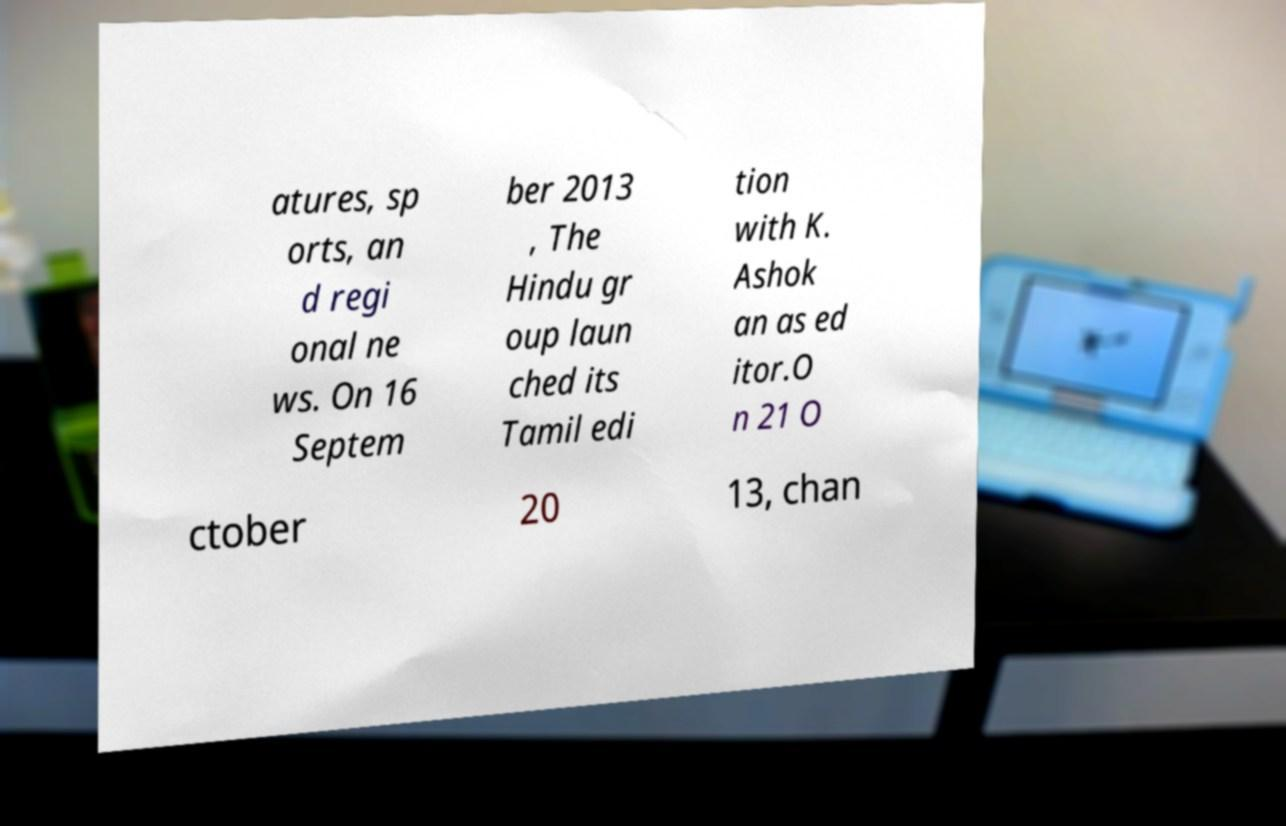For documentation purposes, I need the text within this image transcribed. Could you provide that? atures, sp orts, an d regi onal ne ws. On 16 Septem ber 2013 , The Hindu gr oup laun ched its Tamil edi tion with K. Ashok an as ed itor.O n 21 O ctober 20 13, chan 